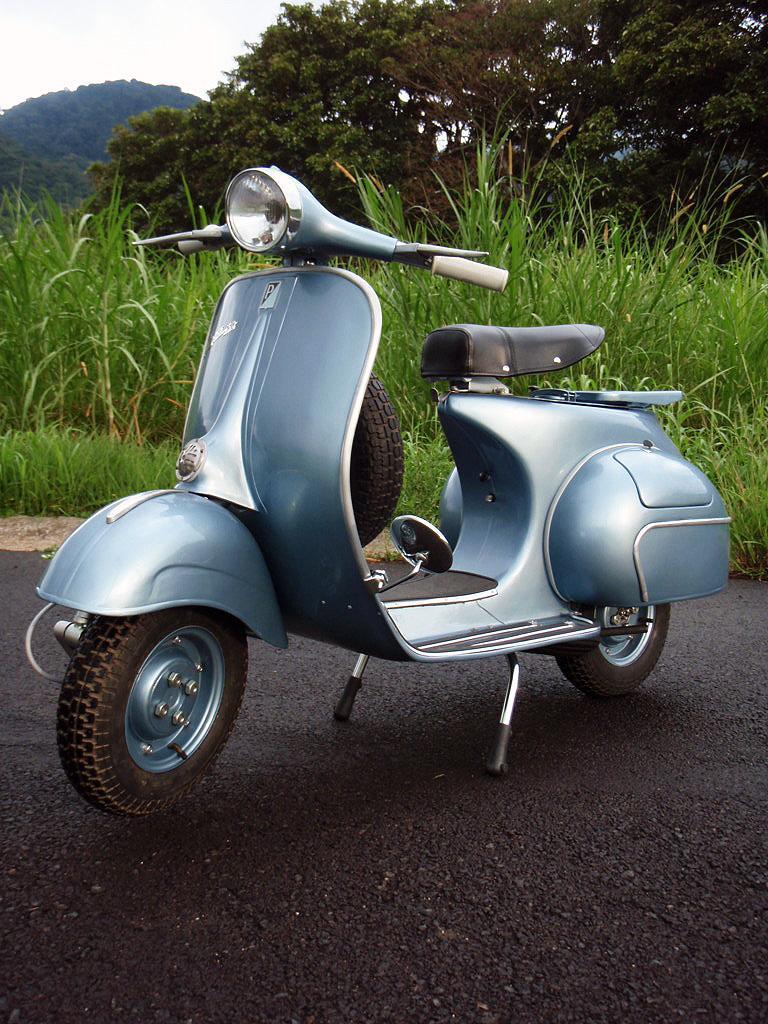How would you summarize this image in a sentence or two? This picture is clicked outside. In the center we can see a vehicle is parked on the ground and we can see the green grass, plants and trees. In the background we can see the sky and the trees. 